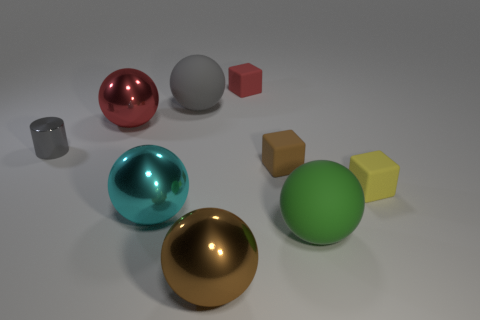What materials are represented by the different objects in this image? The objects in the image appear to represent various materials: the shiny spheres could be metallic, the cubes seem to be matte, possibly simulating plastics or wood, and the cylindrical object has a reflective surface akin to polished stone or ceramic. 